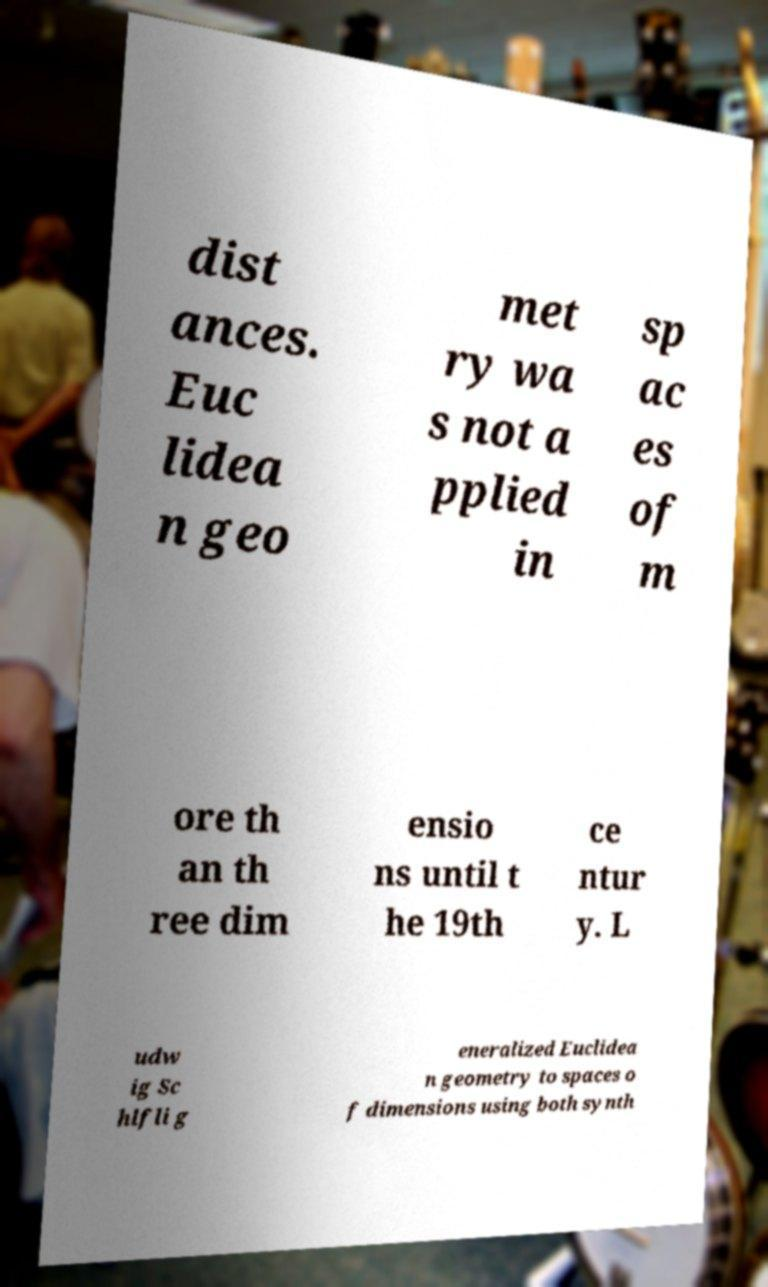What messages or text are displayed in this image? I need them in a readable, typed format. dist ances. Euc lidea n geo met ry wa s not a pplied in sp ac es of m ore th an th ree dim ensio ns until t he 19th ce ntur y. L udw ig Sc hlfli g eneralized Euclidea n geometry to spaces o f dimensions using both synth 